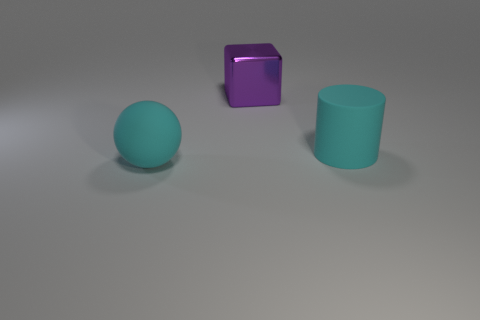Add 2 large spheres. How many objects exist? 5 Subtract all balls. How many objects are left? 2 Add 3 large balls. How many large balls are left? 4 Add 3 red matte cylinders. How many red matte cylinders exist? 3 Subtract 1 cyan cylinders. How many objects are left? 2 Subtract all large cyan things. Subtract all tiny blue cubes. How many objects are left? 1 